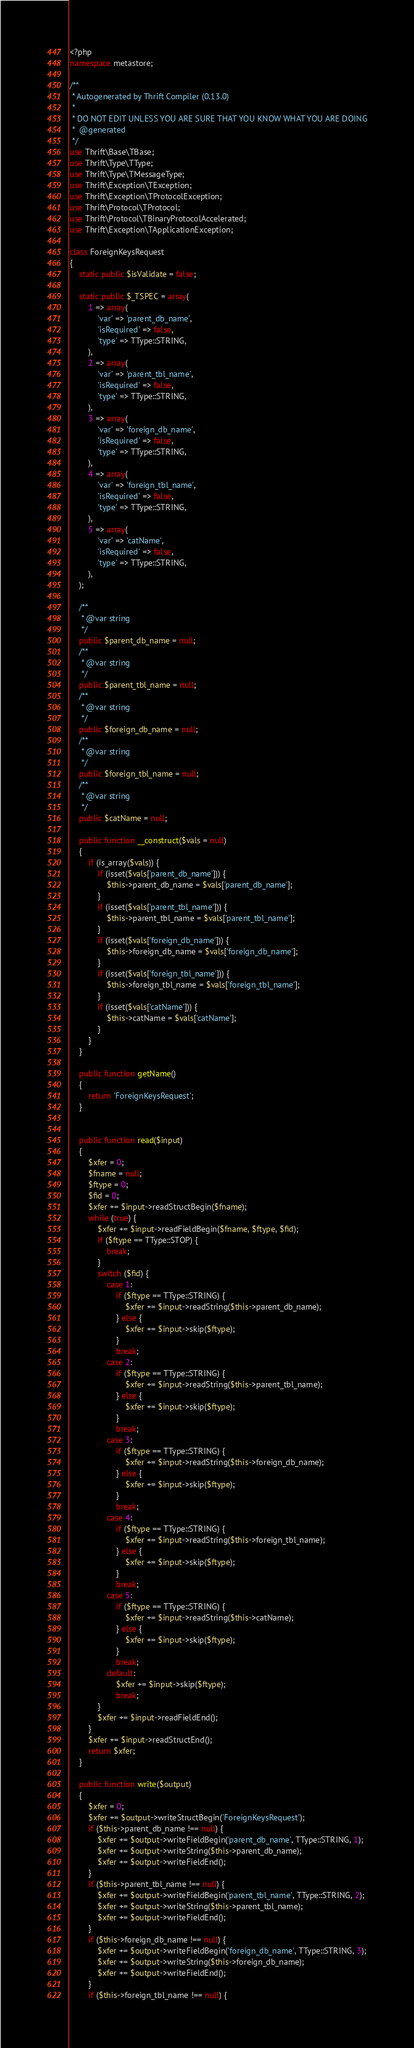<code> <loc_0><loc_0><loc_500><loc_500><_PHP_><?php
namespace metastore;

/**
 * Autogenerated by Thrift Compiler (0.13.0)
 *
 * DO NOT EDIT UNLESS YOU ARE SURE THAT YOU KNOW WHAT YOU ARE DOING
 *  @generated
 */
use Thrift\Base\TBase;
use Thrift\Type\TType;
use Thrift\Type\TMessageType;
use Thrift\Exception\TException;
use Thrift\Exception\TProtocolException;
use Thrift\Protocol\TProtocol;
use Thrift\Protocol\TBinaryProtocolAccelerated;
use Thrift\Exception\TApplicationException;

class ForeignKeysRequest
{
    static public $isValidate = false;

    static public $_TSPEC = array(
        1 => array(
            'var' => 'parent_db_name',
            'isRequired' => false,
            'type' => TType::STRING,
        ),
        2 => array(
            'var' => 'parent_tbl_name',
            'isRequired' => false,
            'type' => TType::STRING,
        ),
        3 => array(
            'var' => 'foreign_db_name',
            'isRequired' => false,
            'type' => TType::STRING,
        ),
        4 => array(
            'var' => 'foreign_tbl_name',
            'isRequired' => false,
            'type' => TType::STRING,
        ),
        5 => array(
            'var' => 'catName',
            'isRequired' => false,
            'type' => TType::STRING,
        ),
    );

    /**
     * @var string
     */
    public $parent_db_name = null;
    /**
     * @var string
     */
    public $parent_tbl_name = null;
    /**
     * @var string
     */
    public $foreign_db_name = null;
    /**
     * @var string
     */
    public $foreign_tbl_name = null;
    /**
     * @var string
     */
    public $catName = null;

    public function __construct($vals = null)
    {
        if (is_array($vals)) {
            if (isset($vals['parent_db_name'])) {
                $this->parent_db_name = $vals['parent_db_name'];
            }
            if (isset($vals['parent_tbl_name'])) {
                $this->parent_tbl_name = $vals['parent_tbl_name'];
            }
            if (isset($vals['foreign_db_name'])) {
                $this->foreign_db_name = $vals['foreign_db_name'];
            }
            if (isset($vals['foreign_tbl_name'])) {
                $this->foreign_tbl_name = $vals['foreign_tbl_name'];
            }
            if (isset($vals['catName'])) {
                $this->catName = $vals['catName'];
            }
        }
    }

    public function getName()
    {
        return 'ForeignKeysRequest';
    }


    public function read($input)
    {
        $xfer = 0;
        $fname = null;
        $ftype = 0;
        $fid = 0;
        $xfer += $input->readStructBegin($fname);
        while (true) {
            $xfer += $input->readFieldBegin($fname, $ftype, $fid);
            if ($ftype == TType::STOP) {
                break;
            }
            switch ($fid) {
                case 1:
                    if ($ftype == TType::STRING) {
                        $xfer += $input->readString($this->parent_db_name);
                    } else {
                        $xfer += $input->skip($ftype);
                    }
                    break;
                case 2:
                    if ($ftype == TType::STRING) {
                        $xfer += $input->readString($this->parent_tbl_name);
                    } else {
                        $xfer += $input->skip($ftype);
                    }
                    break;
                case 3:
                    if ($ftype == TType::STRING) {
                        $xfer += $input->readString($this->foreign_db_name);
                    } else {
                        $xfer += $input->skip($ftype);
                    }
                    break;
                case 4:
                    if ($ftype == TType::STRING) {
                        $xfer += $input->readString($this->foreign_tbl_name);
                    } else {
                        $xfer += $input->skip($ftype);
                    }
                    break;
                case 5:
                    if ($ftype == TType::STRING) {
                        $xfer += $input->readString($this->catName);
                    } else {
                        $xfer += $input->skip($ftype);
                    }
                    break;
                default:
                    $xfer += $input->skip($ftype);
                    break;
            }
            $xfer += $input->readFieldEnd();
        }
        $xfer += $input->readStructEnd();
        return $xfer;
    }

    public function write($output)
    {
        $xfer = 0;
        $xfer += $output->writeStructBegin('ForeignKeysRequest');
        if ($this->parent_db_name !== null) {
            $xfer += $output->writeFieldBegin('parent_db_name', TType::STRING, 1);
            $xfer += $output->writeString($this->parent_db_name);
            $xfer += $output->writeFieldEnd();
        }
        if ($this->parent_tbl_name !== null) {
            $xfer += $output->writeFieldBegin('parent_tbl_name', TType::STRING, 2);
            $xfer += $output->writeString($this->parent_tbl_name);
            $xfer += $output->writeFieldEnd();
        }
        if ($this->foreign_db_name !== null) {
            $xfer += $output->writeFieldBegin('foreign_db_name', TType::STRING, 3);
            $xfer += $output->writeString($this->foreign_db_name);
            $xfer += $output->writeFieldEnd();
        }
        if ($this->foreign_tbl_name !== null) {</code> 